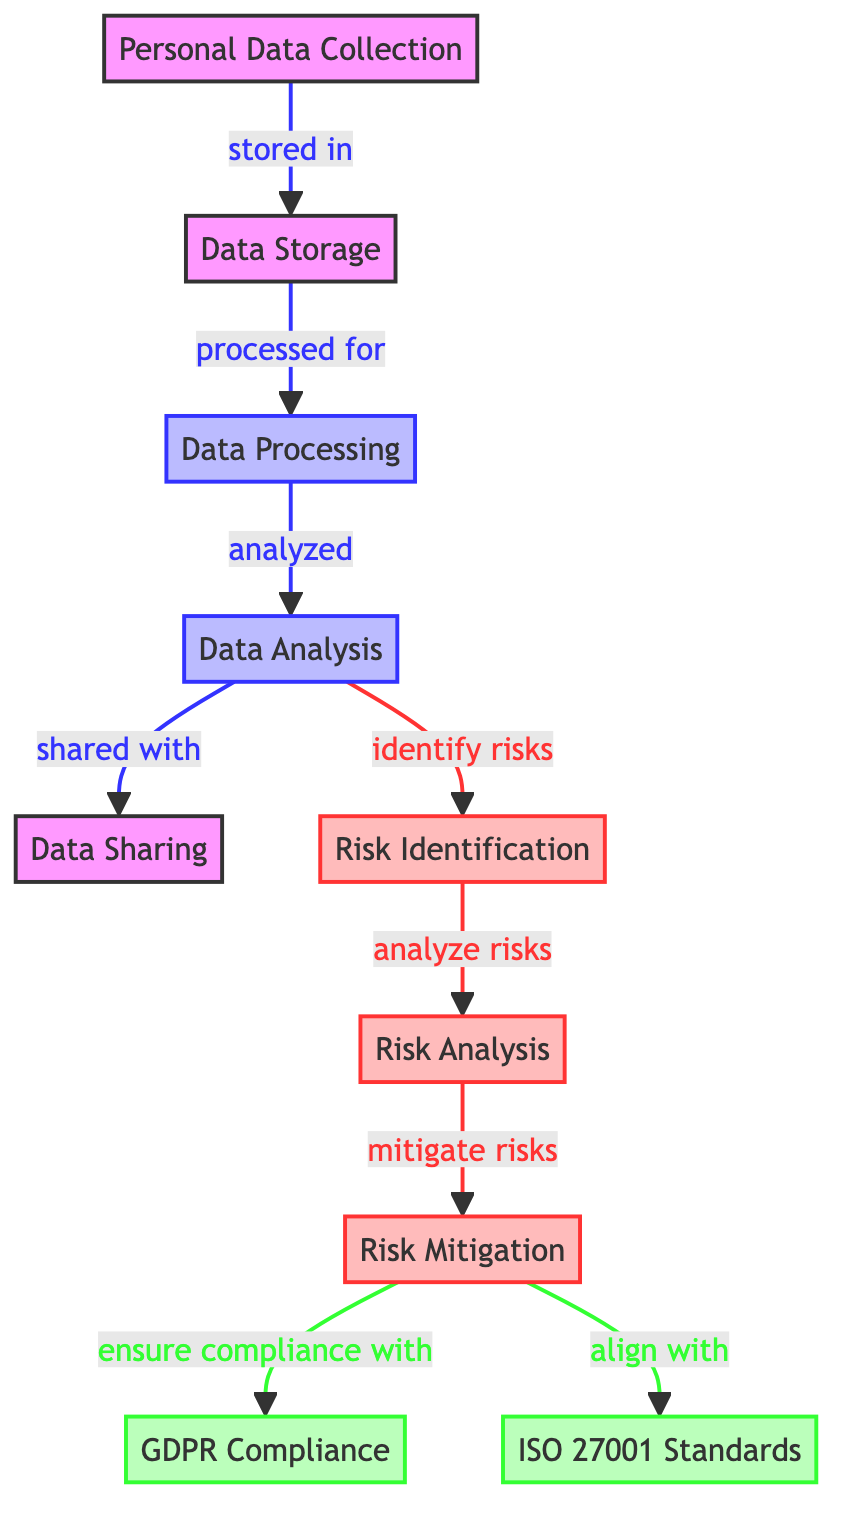What is the first step in the data flow? The first step in the data flow, as depicted by the diagram, is the Personal Data Collection. This is indicated as the starting node that has an arrow leading to the Data Storage node.
Answer: Personal Data Collection How many processing activities are represented in the diagram? The diagram includes two processing activities: Data Processing and Data Analysis. Both are indicated as process nodes, contributing to the total count of processing activities in the visual representation.
Answer: 2 Which activity is immediately after Data Storage? The activity that follows Data Storage is Data Processing, as shown by the arrow leading from the Data Storage node directly to the Data Processing node, indicating the flow of data.
Answer: Data Processing What does Risk Mitigation ensure compliance with? Risk Mitigation ensures compliance with GDPR, as indicated by the arrow that shows the connection from the Risk Mitigation node to the GDPR Compliance node, establishing this relationship.
Answer: GDPR Compliance What are the two standards aligned with Risk Mitigation? The two standards aligned with Risk Mitigation are GDPR Compliance and ISO 27001 Standards, as both have direct connections (arrows) leading from the Risk Mitigation node, indicating the compliance requirements involved.
Answer: GDPR Compliance and ISO 27001 Standards Why is Risk Analysis necessary after Risk Identification? Risk Analysis is necessary after Risk Identification to evaluate the risks that have been identified previously. The diagram shows that the Risk Identification node connects directly to the Risk Analysis node, highlighting the sequential flow of risk management activities.
Answer: To evaluate identified risks What is the role of Data Analysis in the diagram? The role of Data Analysis is twofold: it is responsible for analyzing the processed data and for identifying risks associated with the data. The diagram shows arrows leading from Data Analysis to both Data Sharing and Risk Identification nodes, clearly depicting these functions.
Answer: Analyze data and identify risks How does Data Sharing relate to other processes? Data Sharing relates to the processes as it is the end stage where analyzed data is shared. It follows the Data Analysis process, indicated by an arrow that demonstrates the transition of data flow from Data Analysis to Data Sharing.
Answer: It's the end stage after analysis What is the significance of the compliance nodes? The compliance nodes (GDPR Compliance and ISO 27001 Standards) signify the necessary regulations and standards that must be followed as part of the risk mitigation process. These nodes are linked directly to the Risk Mitigation node, indicating that compliance is a fundamental outcome of risk management activities.
Answer: Necessary regulations and standards 